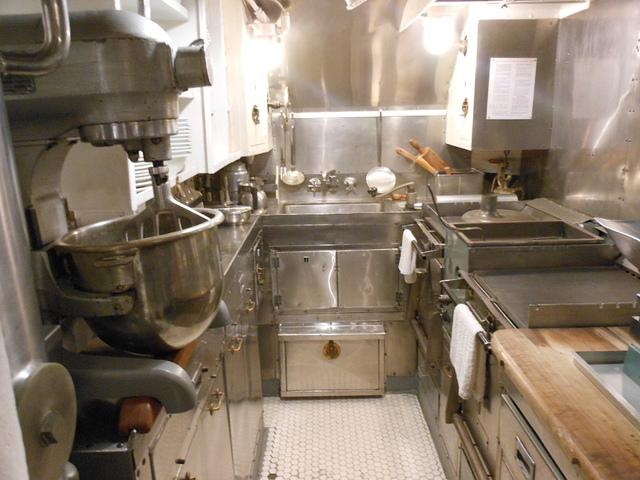How is dough kneaded here? machine 